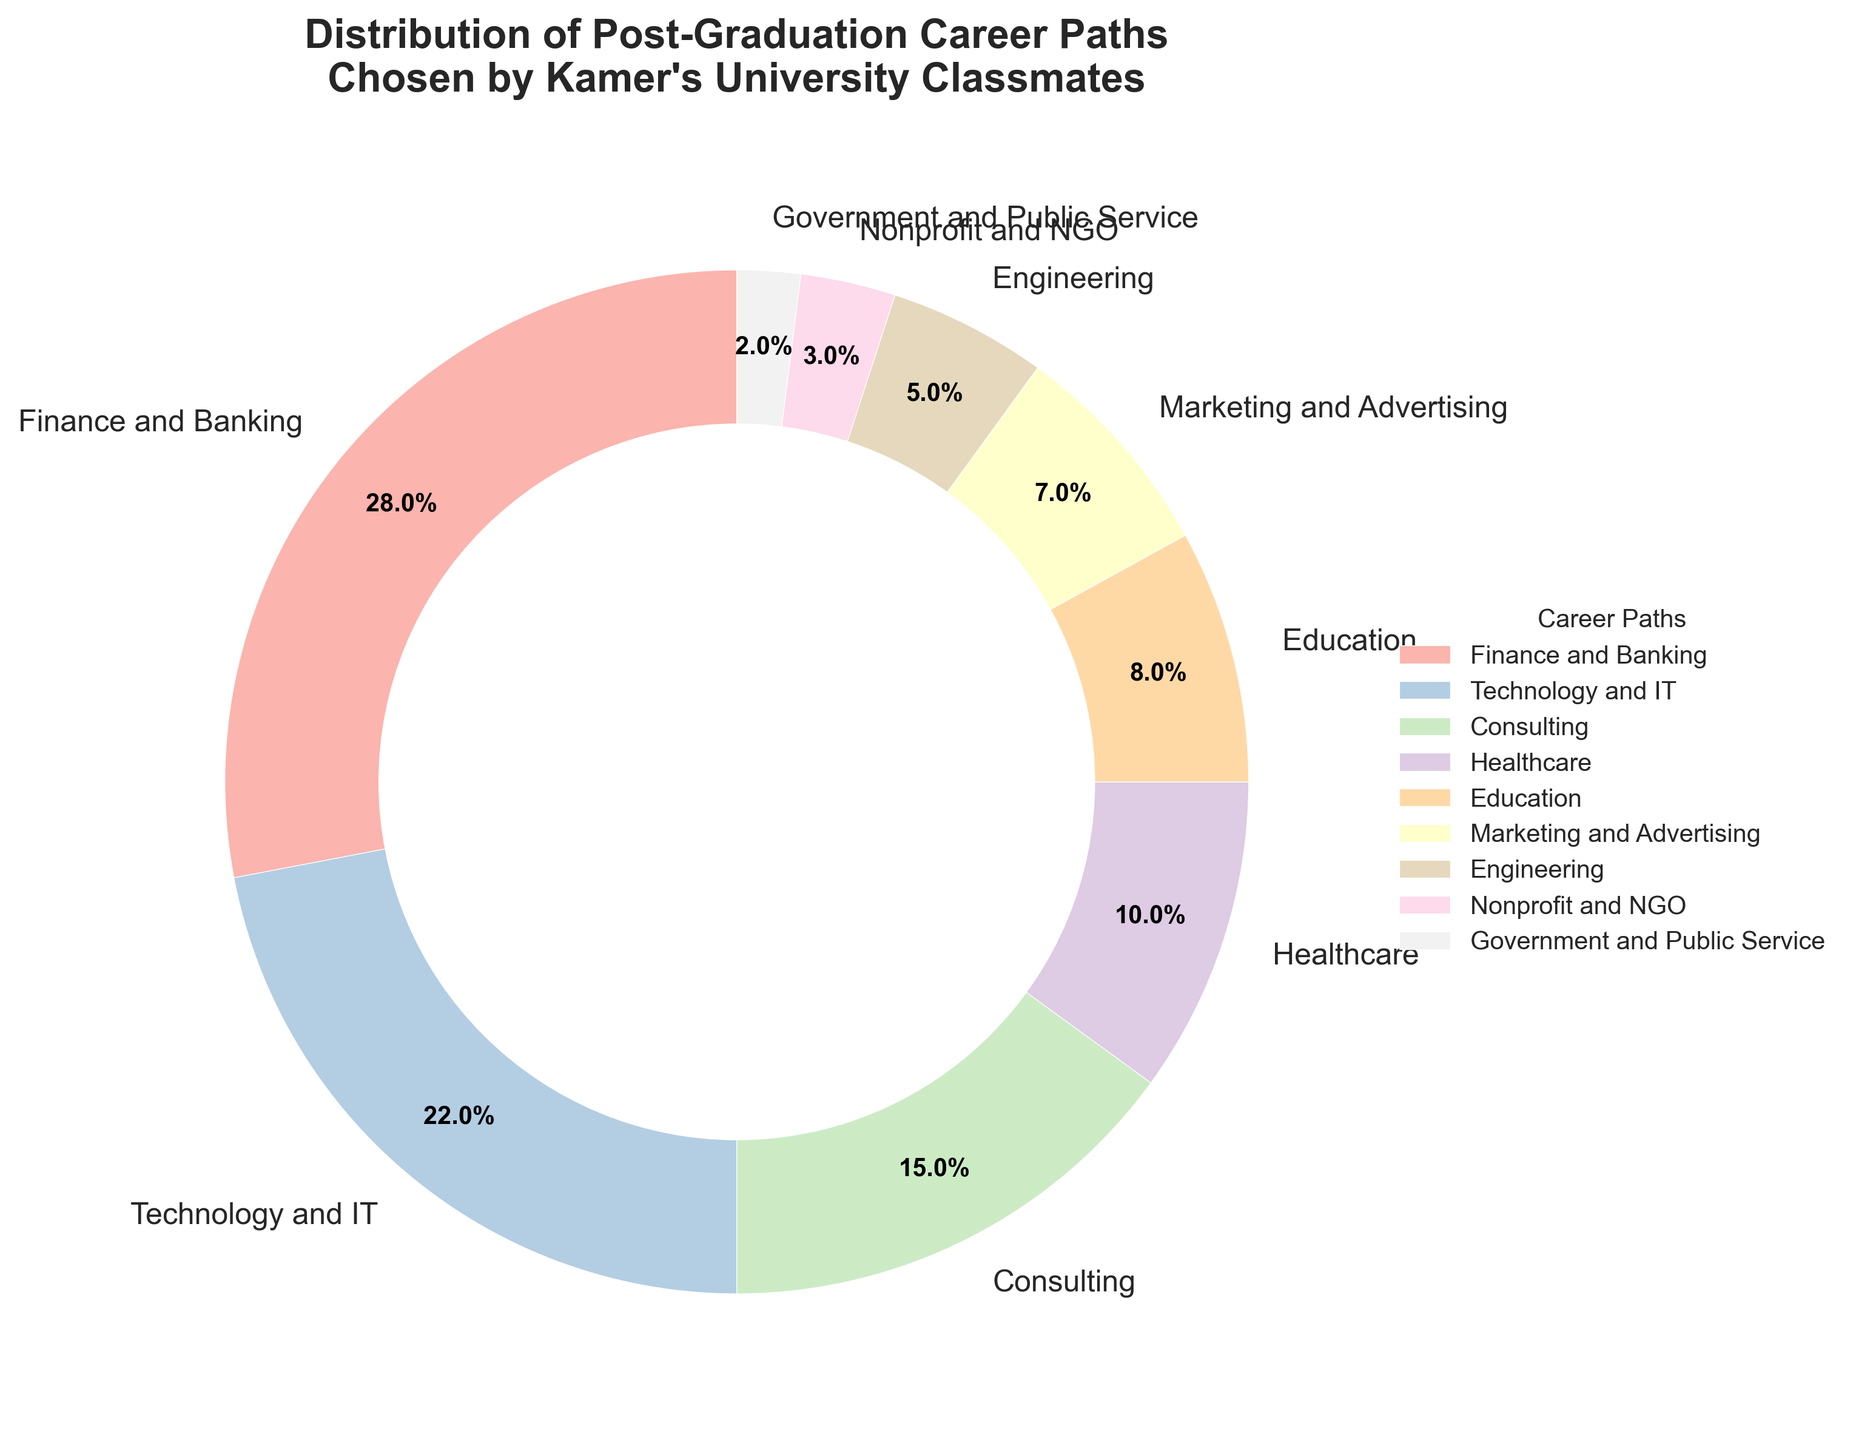What percentage of Kamer's university classmates pursued careers in Technology and IT? The figure shows different segments representing various career paths, with percentages. The Technology and IT segment is labeled 22%.
Answer: 22% Which career path was chosen by the least number of classmates, and what percentage was it? Look for the smallest segment in the pie chart, which is labeled as Government and Public Service with 2%.
Answer: Government and Public Service, 2% What is the combined percentage of classmates working in Engineering, Marketing and Advertising, and Education? Add the percentages for Engineering (5%), Marketing and Advertising (7%), and Education (8%). Total is 5% + 7% + 8% = 20%.
Answer: 20% How does the percentage of classmates in Finance and Banking compare to those in Technology and IT? Compare the labels: Finance and Banking is 28%, and Technology and IT is 22%. Finance and Banking has a higher percentage (28% is greater than 22%).
Answer: Finance and Banking has a higher percentage What is the difference in percentage between classmates in Consulting and Healthcare? Subtract the percentage of Healthcare (10%) from Consulting (15%). The difference is 15% - 10% = 5%.
Answer: 5% How many career paths have at least 10% of classmates? Identify the segments with percentages 10% or higher: Finance and Banking (28%), Technology and IT (22%), Consulting (15%), and Healthcare (10%). There are 4 such career paths.
Answer: 4 What is the median percentage of the career paths listed? First, list the percentages in order: 2, 3, 5, 7, 8, 10, 15, 22, 28. The middle value or median is 8.
Answer: 8 Which career path grayscale is lighter, Technology and IT or Healthcare? The pie chart uses different colors, generally lighter colors reflect less dense appearances. Comparing the two segments visually, Technology and IT (pale color) appears lighter than Healthcare (slightly more saturated color).
Answer: Technology and IT If we combine the percentages of Nonprofit and NGO, and Government and Public Service, how much do they account for? Add the percentages for Nonprofit and NGO (3%) and Government and Public Service (2%). Total is 3% + 2% = 5%.
Answer: 5% Which career paths make up exactly one-third (33.3%) of the whole? Add combinations of percentages to find the set that sums closest to 33.3%: Finance and Banking (28%) + Government and Public Service (2%) + Nonprofit and NGO (3%) = 33%.
Answer: Finance and Banking, Government and Public Service, Nonprofit and NGO 